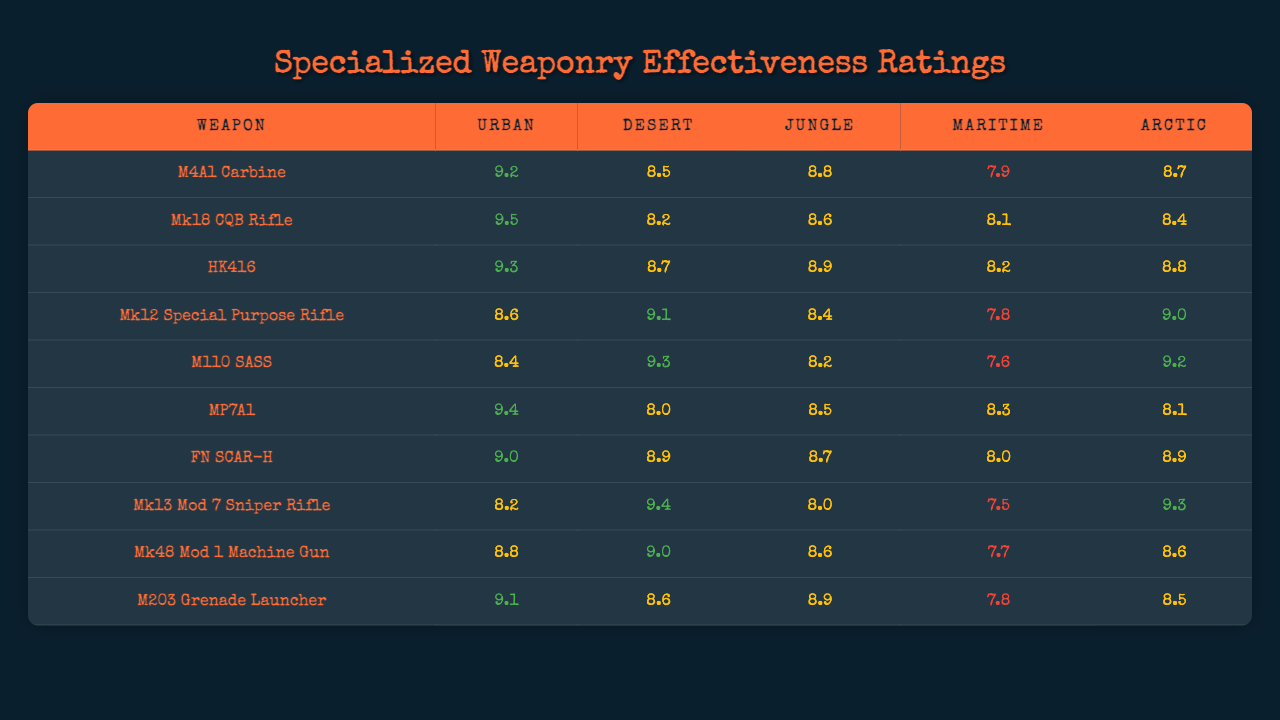What is the effectiveness rating of the M4A1 Carbine in the Urban environment? According to the table, the effectiveness rating of the M4A1 Carbine in the Urban environment is listed as 9.2.
Answer: 9.2 Which weapon has the highest effectiveness rating in the Desert environment? Reviewing the Desert ratings in the table, the M110 SASS has the highest effectiveness rating at 9.3.
Answer: M110 SASS What is the average effectiveness rating of the Mk48 Mod 1 Machine Gun across all environments? To find the average, sum the ratings of the Mk48 Mod 1: (8.8 + 9.0 + 8.6 + 7.7 + 8.6) = 42.7. Then, divide by 5 (the number of environments): 42.7/5 = 8.54.
Answer: 8.54 Is the Mk12 Special Purpose Rifle rated above 9.0 in the Arctic environment? The table shows that the Mk12 Special Purpose Rifle has a rating of 9.0 in the Arctic environment, which is equal to 9.0, thus the answer is no.
Answer: No What is the difference in effectiveness ratings between the HK416 and the Mk18 CQB Rifle in the Jungle environment? For the Jungle environment, the HK416 has a rating of 8.9 and the Mk18 CQB Rifle has a rating of 8.6. Therefore, the difference is 8.9 - 8.6 = 0.3.
Answer: 0.3 Which weapon performs best in the Maritime environment, and how does its effectiveness compare to the lowest-rated weapon in that environment? The weapon that performs best in the Maritime environment is the HK416 with a rating of 8.2. The lowest-rated weapon is the Mk12 Special Purpose Rifle with a rating of 7.8. The difference in effectiveness is 8.2 - 7.8 = 0.4.
Answer: Best: HK416; Difference: 0.4 Which weapon has the most consistent ratings across all environments? Analyzing the ratings for each weapon, the Mk48 Mod 1 Machine Gun has the least variation, with ratings of 8.8, 9.0, 8.6, 7.7, and 8.6. The highest rating is 9.0 and the lowest is 7.7.
Answer: Mk48 Mod 1 Machine Gun Is the average rating for the M203 Grenade Launcher above 8.5? The ratings for the M203 are 9.1, 8.6, 8.9, 7.8, and 8.5. The sum is 43.9, dividing by 5 gives an average of 43.9/5 = 8.78, which is above 8.5.
Answer: Yes What percentage of weapons have an effectiveness rating of 9.0 or higher in the Urban environment? In the Urban environment, the weapons that have a rating of 9.0 or higher are the M4A1 Carbine, Mk18 CQB Rifle, HK416, MP7A1, FN SCAR-H, and M203 Grenade Launcher, totaling 6 weapons out of 10. Thus, the percentage is (6/10) * 100 = 60%.
Answer: 60% How does the performance of the M110 SASS in the Desert compare to its performance in the Arctic? The M110 SASS has a rating of 9.3 in the Desert and 9.2 in the Arctic. To determine the comparison, we look at the difference, which is 9.3 - 9.2 = 0.1, indicating it performs slightly better in the Desert.
Answer: Better in Desert by 0.1 